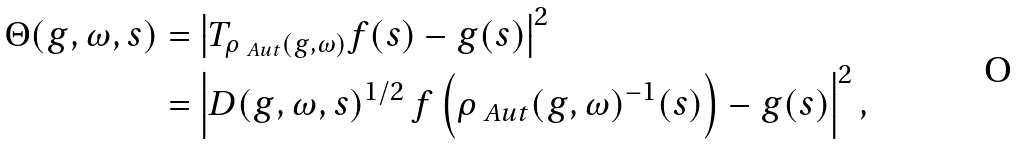<formula> <loc_0><loc_0><loc_500><loc_500>\Theta ( g , \omega , s ) & = \left | T _ { \rho _ { \ A u t } ( g , \omega ) } f ( s ) - g ( s ) \right | ^ { 2 } \\ & = \left | D ( g , \omega , s ) ^ { 1 / 2 } \, f \left ( \rho _ { \ A u t } ( g , \omega ) ^ { - 1 } ( s ) \right ) - g ( s ) \right | ^ { 2 } ,</formula> 